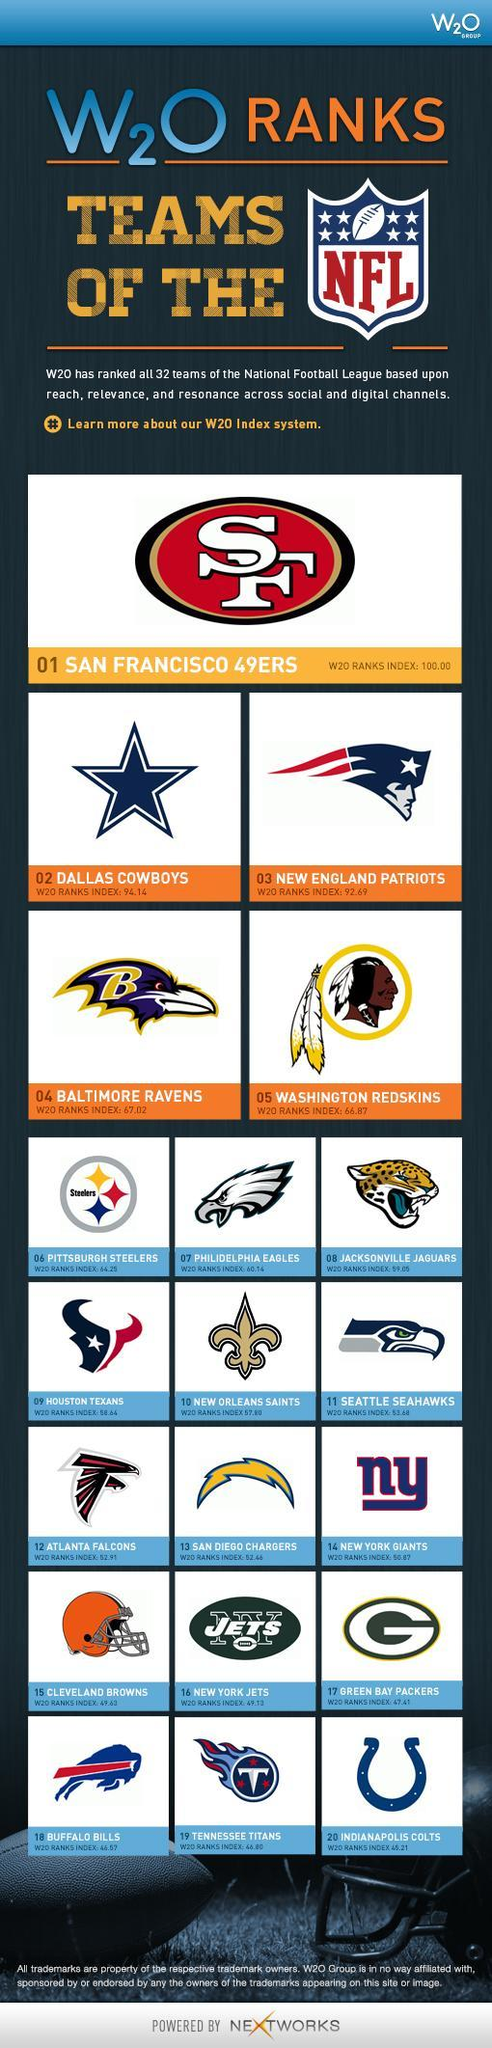How many NFL teams are there?
Answer the question with a short phrase. 32 Which NFL team has the second-highest W20 rank index? DALLAS COWBOYS Which NFL team has the lowest W20 rank index? INDIANAPOLIS COLTS 